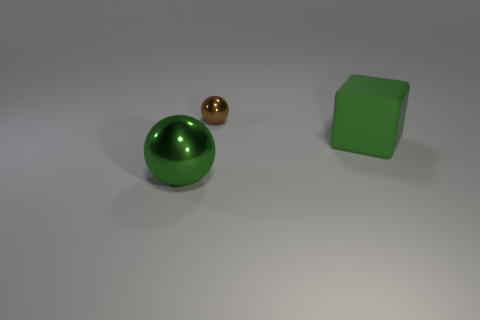Is there any other thing that is made of the same material as the block?
Your answer should be very brief. No. The thing that is the same material as the small brown sphere is what color?
Give a very brief answer. Green. Is there anything else that is the same size as the brown object?
Offer a very short reply. No. There is a big metal object; what number of green objects are in front of it?
Your answer should be compact. 0. Is the color of the large thing behind the large shiny thing the same as the metal ball that is in front of the large green cube?
Offer a terse response. Yes. There is a big thing that is the same shape as the small brown thing; what is its color?
Provide a succinct answer. Green. Is there anything else that has the same shape as the big green matte thing?
Offer a terse response. No. There is a green object on the right side of the small brown metallic object; does it have the same shape as the shiny object on the right side of the big metallic ball?
Keep it short and to the point. No. There is a rubber thing; is it the same size as the thing that is in front of the green cube?
Provide a succinct answer. Yes. Is the number of green spheres greater than the number of purple blocks?
Make the answer very short. Yes. 